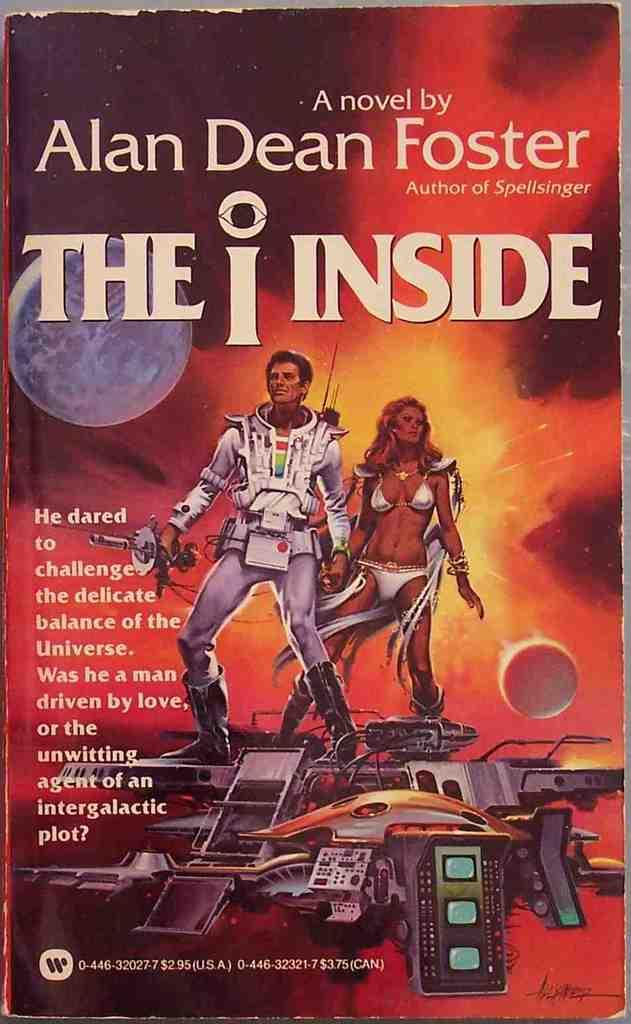<image>
Describe the image concisely. the cover of novel The Inside by Alan Dean Foster 